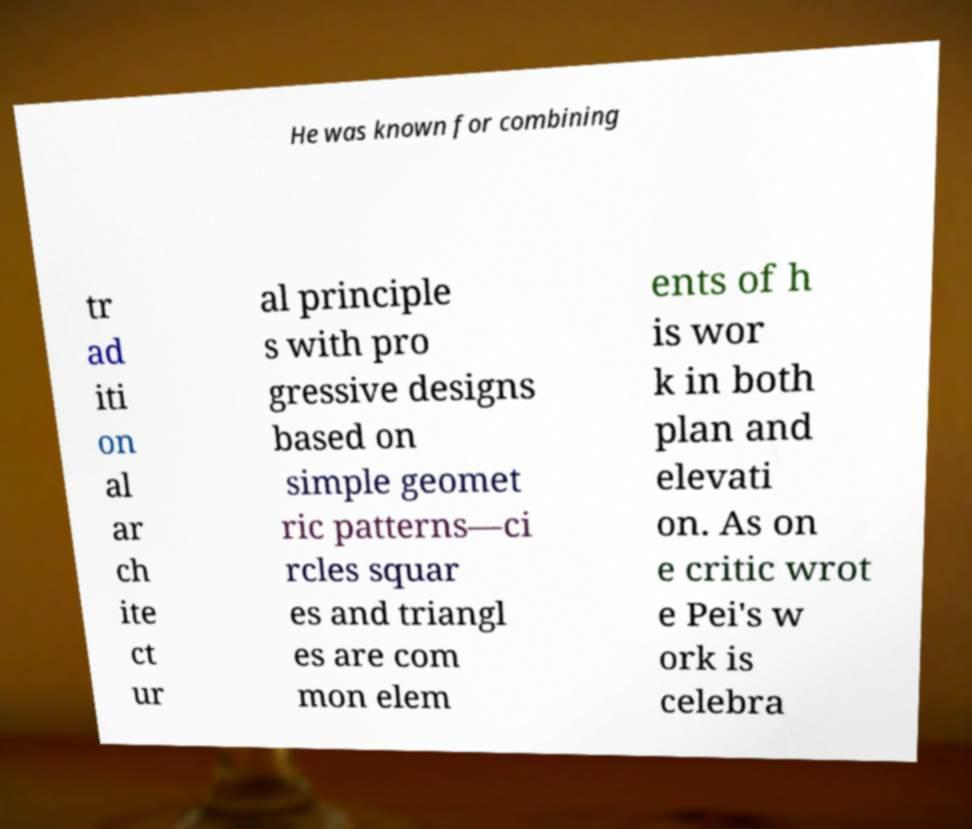Please identify and transcribe the text found in this image. He was known for combining tr ad iti on al ar ch ite ct ur al principle s with pro gressive designs based on simple geomet ric patterns—ci rcles squar es and triangl es are com mon elem ents of h is wor k in both plan and elevati on. As on e critic wrot e Pei's w ork is celebra 